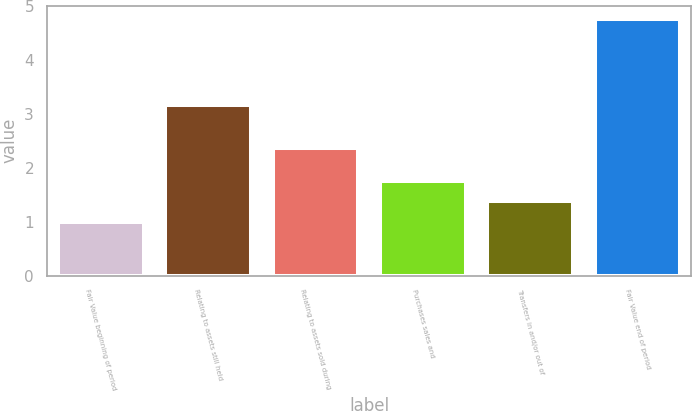Convert chart. <chart><loc_0><loc_0><loc_500><loc_500><bar_chart><fcel>Fair Value beginning of period<fcel>Relating to assets still held<fcel>Relating to assets sold during<fcel>Purchases sales and<fcel>Transfers in and/or out of<fcel>Fair Value end of period<nl><fcel>1<fcel>3.16<fcel>2.37<fcel>1.76<fcel>1.38<fcel>4.77<nl></chart> 